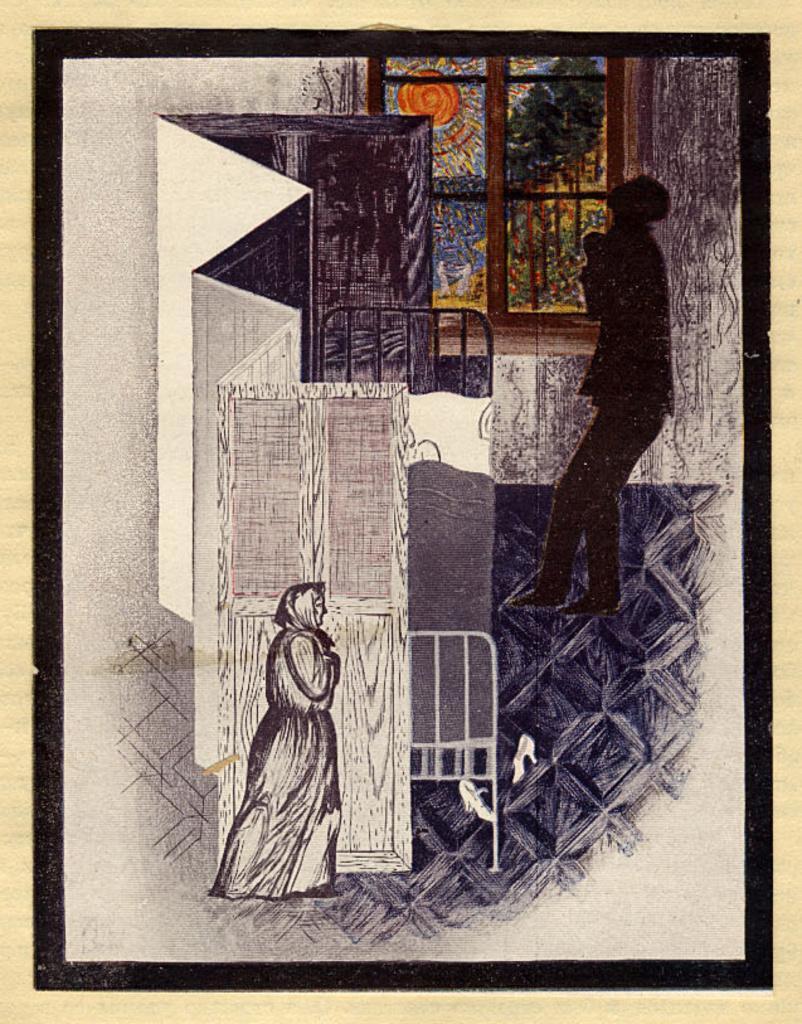In one or two sentences, can you explain what this image depicts? This picture shows a painting. We see a woman and human. 